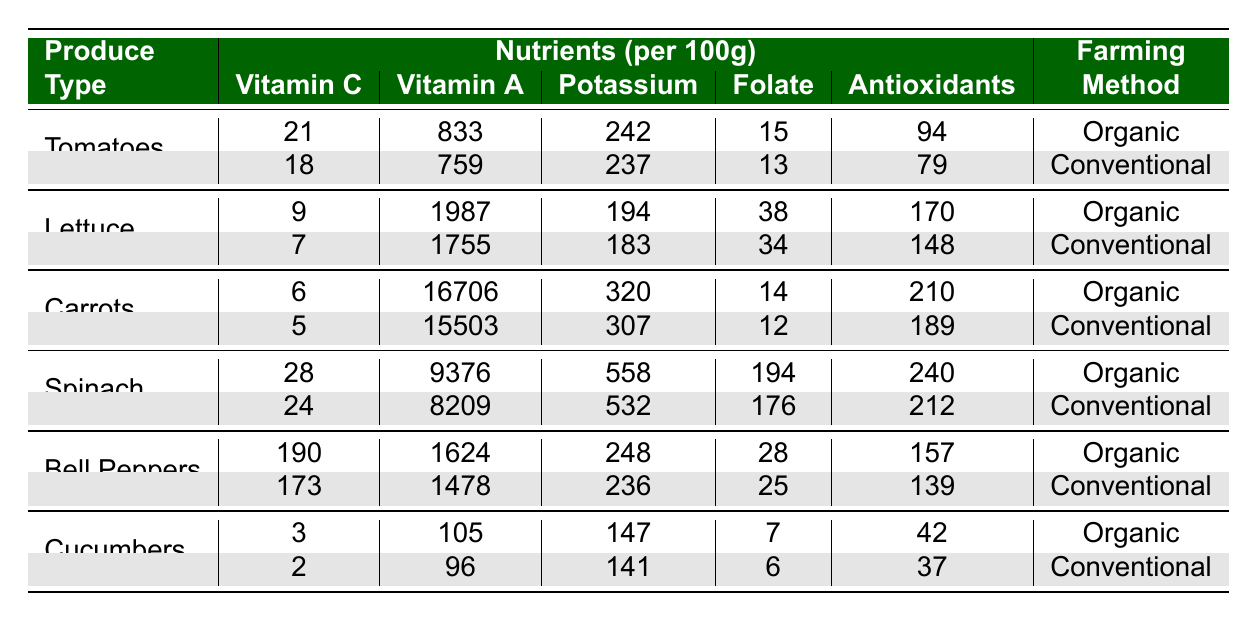What is the Vitamin C content of organic tomatoes? According to the table, the Vitamin C content for organic tomatoes is listed directly. It shows 21mg of Vitamin C per 100g of organic tomatoes.
Answer: 21mg What is the difference in Vitamin A content between organic and conventional carrots? For organic carrots, the Vitamin A content is 16706, and for conventional carrots, it is 15503. The difference is calculated as 16706 - 15503 = 203.
Answer: 203 Is the Potassium content higher in conventional spinach compared to organic spinach? The Potassium content for organic spinach is 558, while for conventional spinach, it is 532. Since 558 is greater than 532, the statement is false.
Answer: No What is the average Antioxidant content for all organic produce? Adding the Antioxidants for each organic produce type: 94 (Tomatoes) + 170 (Lettuce) + 210 (Carrots) + 240 (Spinach) + 157 (Bell Peppers) + 42 (Cucumbers) = 913. There are 6 types, so the average is 913 / 6 = 152.17.
Answer: 152.17 What produce type has the highest Vitamin C content in both farming methods? Reviewing the Vitamin C values: 21 (Organic Tomatoes), 18 (Conventional Tomatoes), 9 (Organic Lettuce), 7 (Conventional Lettuce), 6 (Organic Carrots), 5 (Conventional Carrots), 28 (Organic Spinach), 24 (Conventional Spinach), 190 (Organic Bell Peppers), 173 (Conventional Bell Peppers), 3 (Organic Cucumbers), 2 (Conventional Cucumbers). The highest is 190 for organic bell peppers.
Answer: Bell Peppers What is the total Folate content of organic produce types combined? The Folate contents for organic produce are: Tomatoes (15) + Lettuce (38) + Carrots (14) + Spinach (194) + Bell Peppers (28) + Cucumbers (7). Adding these gives: 15 + 38 + 14 + 194 + 28 + 7 = 296.
Answer: 296 Are antioxidants higher in organic lettuce than in conventional lettuce? Organic lettuce has 170 antioxidants, while conventional lettuce has 148. Since 170 is greater than 148, the answer is yes.
Answer: Yes What is the median Vitamin A content for all conventional produce types? The Vitamin A values for conventional produce are: 759 (Tomatoes), 1755 (Lettuce), 15503 (Carrots), 8209 (Spinach), 1478 (Bell Peppers), 96 (Cucumbers). Sorting these values gives: 96, 759, 1478, 1755, 8209, 15503. The median (the average of the 3rd and 4th values) is (1478 + 1755) / 2 = 1666.5.
Answer: 1666.5 Which type of farming method has higher average Vitamin C content? For organic produce: (21 + 9 + 6 + 28 + 190 + 3) = 257. For conventional produce: (18 + 7 + 5 + 24 + 173 + 2) = 229. The averages are 257/6 = 42.83 for organic and 229/6 = 38.17 for conventional. Organic has a higher average.
Answer: Organic Which produce type has the lowest total nutrient value based on Potassium, Folate, and Vitamin C for organic produce? The sum of Potassium, Folate, and Vitamin C for each organic type is: Tomatoes (242 + 15 + 21 = 278), Lettuce (194 + 38 + 9 = 241), Carrots (320 + 14 + 6 = 340), Spinach (558 + 194 + 28 = 780), Bell Peppers (248 + 28 + 190 = 466), Cucumbers (147 + 7 + 3 = 157). The lowest total is from organic cucumbers with 157.
Answer: Cucumbers 